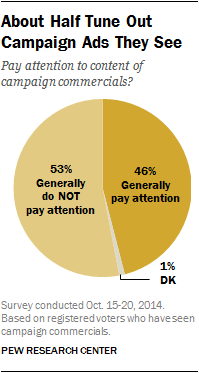Point out several critical features in this image. The value of the largest segment is 0.53. This pie chart is divided into three segments. 